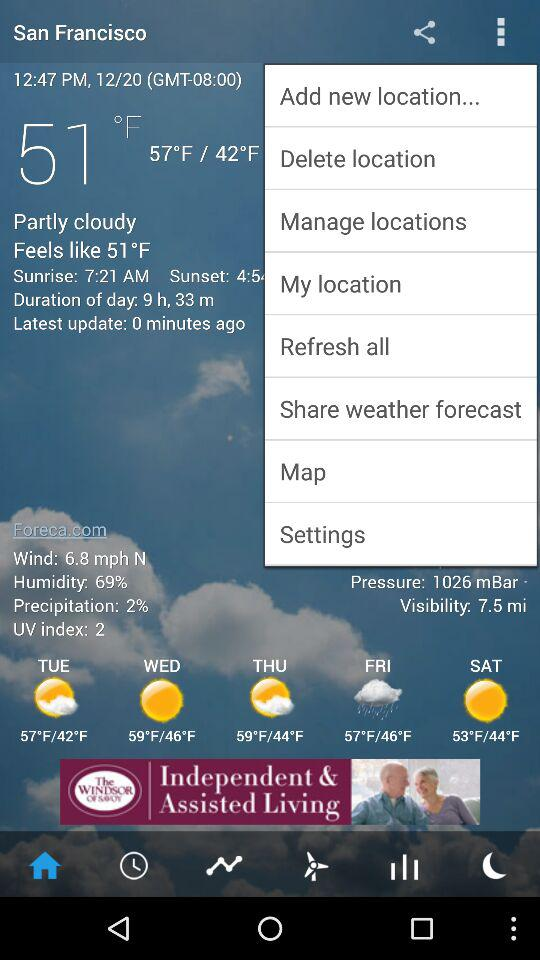What is the time of the sunrise? The time of the sunrise is 7:21 AM. 